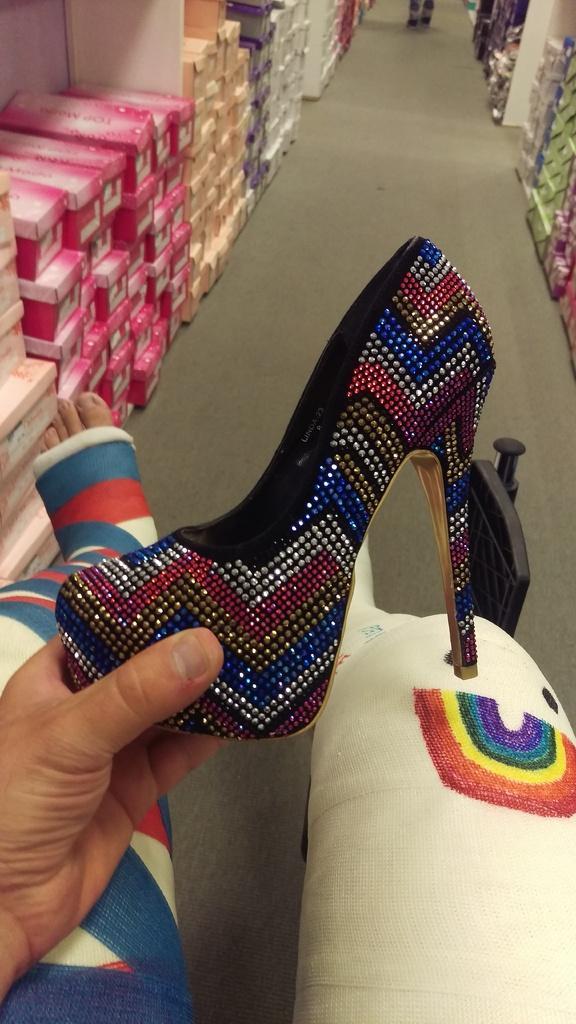In one or two sentences, can you explain what this image depicts? In this picture we can see a person holding a sandal and here we can see some boxes. 